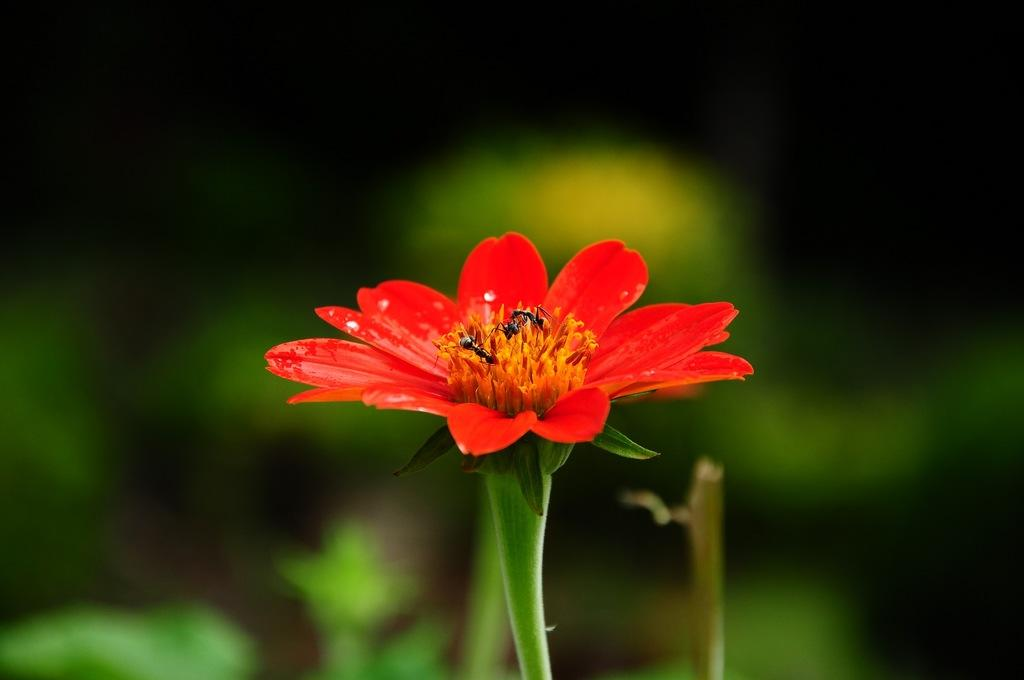What type of flower is in the image? There is a red flower in the image. Are there any insects on the red flower? Yes, there are three ants on the red flower. What can be seen in the background of the image? There are plants in the background of the image. How would you describe the background of the image? The background is blurry. What type of building can be seen in the background of the image? There is no building visible in the image; it only features a red flower, ants, and plants in the background. 